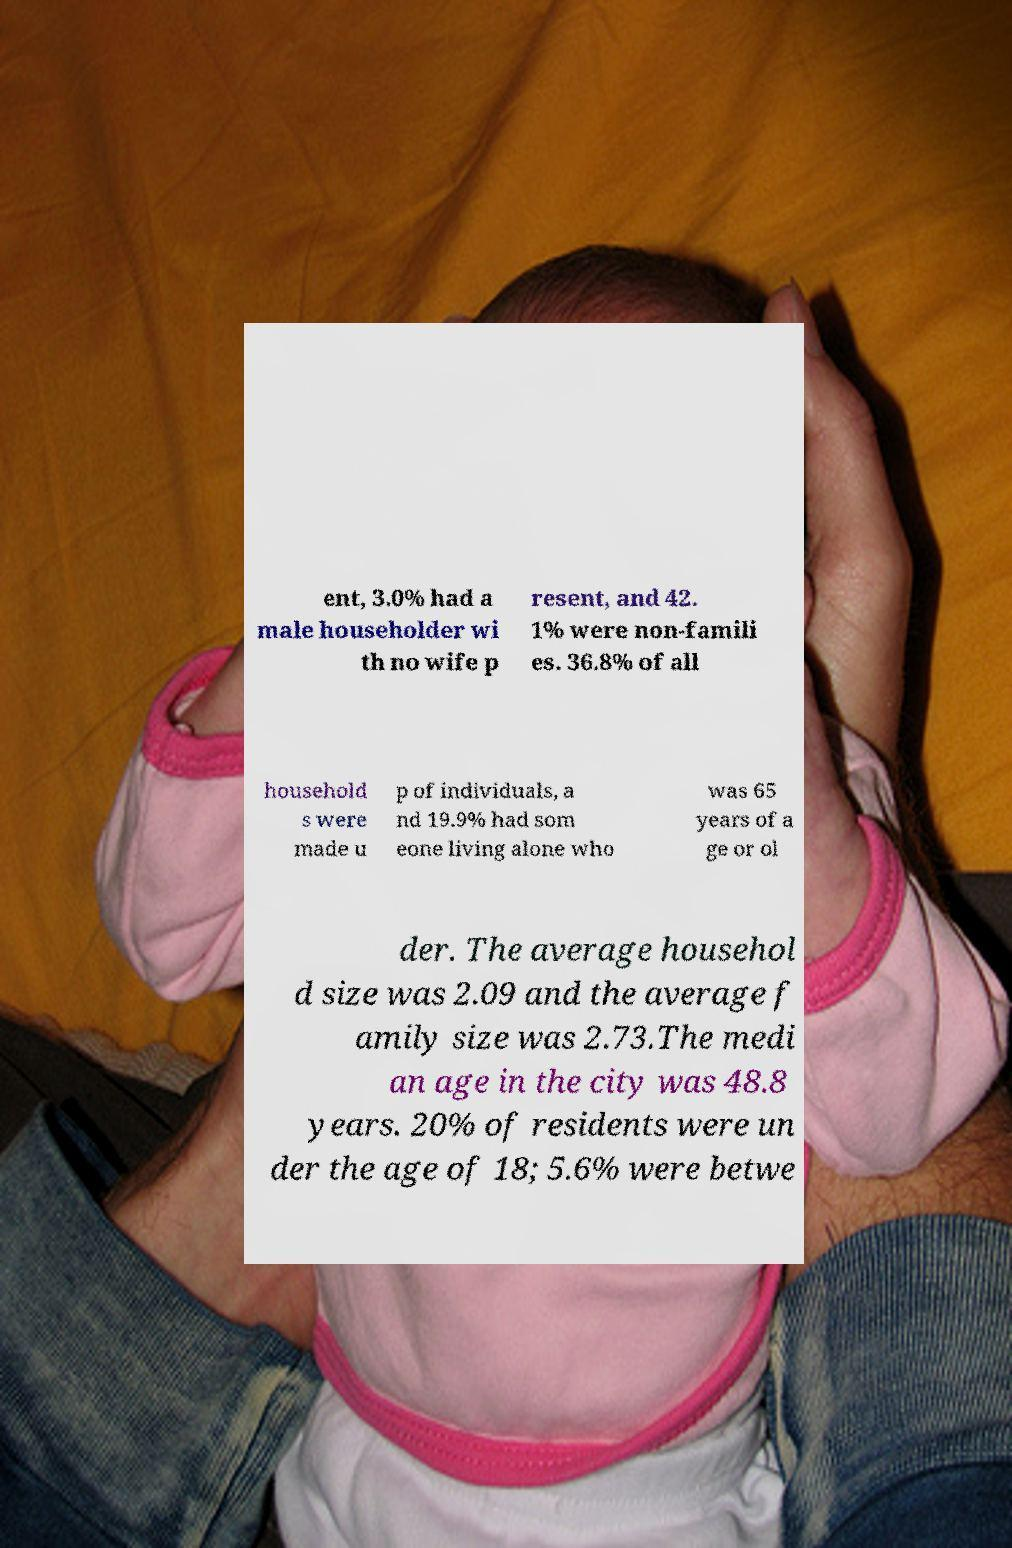Could you extract and type out the text from this image? ent, 3.0% had a male householder wi th no wife p resent, and 42. 1% were non-famili es. 36.8% of all household s were made u p of individuals, a nd 19.9% had som eone living alone who was 65 years of a ge or ol der. The average househol d size was 2.09 and the average f amily size was 2.73.The medi an age in the city was 48.8 years. 20% of residents were un der the age of 18; 5.6% were betwe 